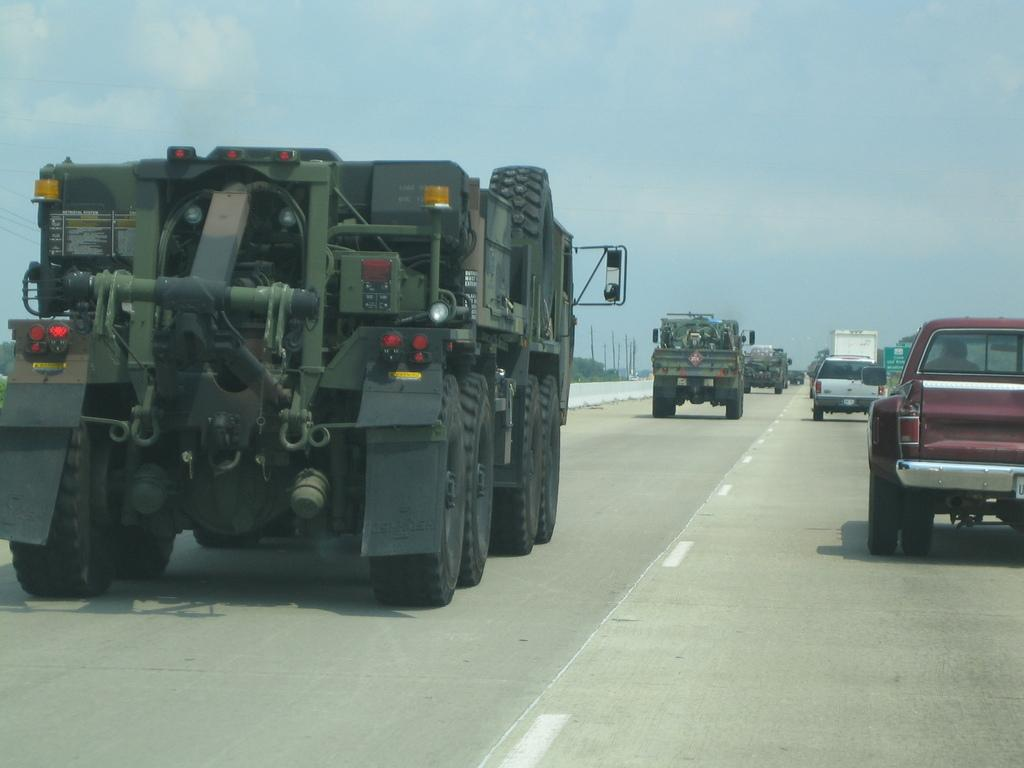What can be seen on the road in the image? There are vehicles on the road in the image. What is visible in the background of the image? There are poles, trees, and the sky visible in the background of the image. Can you see a dog in the middle of the road in the image? There is no dog present in the image; it only shows vehicles on the road. Is there smoke coming from the vehicles in the image? The provided facts do not mention any smoke coming from the vehicles, so we cannot determine that from the image. 